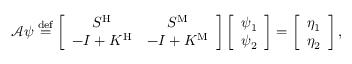<formula> <loc_0><loc_0><loc_500><loc_500>\begin{array} { r } { \mathcal { A } \psi \overset { d e f } { = } \left [ \begin{array} { c c } { S ^ { H } } & { S ^ { M } } \\ { - I + K ^ { H } } & { - I + K ^ { M } } \end{array} \right ] \left [ \begin{array} { c } { \psi _ { 1 } } \\ { \psi _ { 2 } } \end{array} \right ] = \left [ \begin{array} { c } { \eta _ { 1 } } \\ { \eta _ { 2 } } \end{array} \right ] , } \end{array}</formula> 